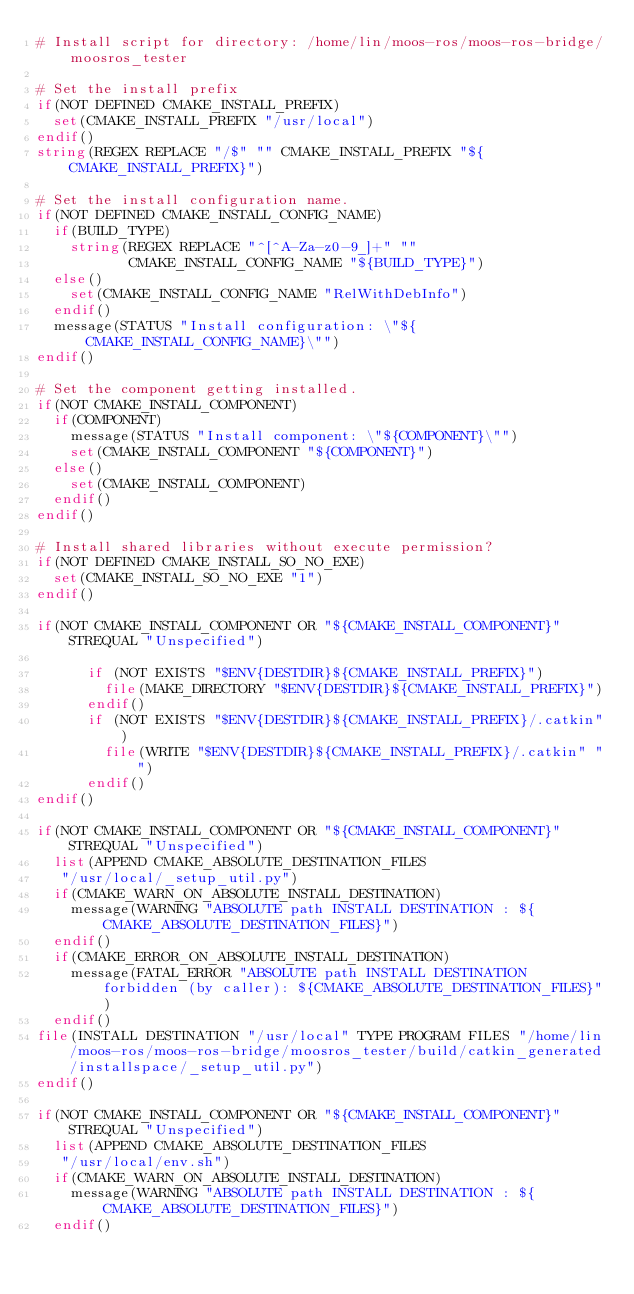Convert code to text. <code><loc_0><loc_0><loc_500><loc_500><_CMake_># Install script for directory: /home/lin/moos-ros/moos-ros-bridge/moosros_tester

# Set the install prefix
if(NOT DEFINED CMAKE_INSTALL_PREFIX)
  set(CMAKE_INSTALL_PREFIX "/usr/local")
endif()
string(REGEX REPLACE "/$" "" CMAKE_INSTALL_PREFIX "${CMAKE_INSTALL_PREFIX}")

# Set the install configuration name.
if(NOT DEFINED CMAKE_INSTALL_CONFIG_NAME)
  if(BUILD_TYPE)
    string(REGEX REPLACE "^[^A-Za-z0-9_]+" ""
           CMAKE_INSTALL_CONFIG_NAME "${BUILD_TYPE}")
  else()
    set(CMAKE_INSTALL_CONFIG_NAME "RelWithDebInfo")
  endif()
  message(STATUS "Install configuration: \"${CMAKE_INSTALL_CONFIG_NAME}\"")
endif()

# Set the component getting installed.
if(NOT CMAKE_INSTALL_COMPONENT)
  if(COMPONENT)
    message(STATUS "Install component: \"${COMPONENT}\"")
    set(CMAKE_INSTALL_COMPONENT "${COMPONENT}")
  else()
    set(CMAKE_INSTALL_COMPONENT)
  endif()
endif()

# Install shared libraries without execute permission?
if(NOT DEFINED CMAKE_INSTALL_SO_NO_EXE)
  set(CMAKE_INSTALL_SO_NO_EXE "1")
endif()

if(NOT CMAKE_INSTALL_COMPONENT OR "${CMAKE_INSTALL_COMPONENT}" STREQUAL "Unspecified")
  
      if (NOT EXISTS "$ENV{DESTDIR}${CMAKE_INSTALL_PREFIX}")
        file(MAKE_DIRECTORY "$ENV{DESTDIR}${CMAKE_INSTALL_PREFIX}")
      endif()
      if (NOT EXISTS "$ENV{DESTDIR}${CMAKE_INSTALL_PREFIX}/.catkin")
        file(WRITE "$ENV{DESTDIR}${CMAKE_INSTALL_PREFIX}/.catkin" "")
      endif()
endif()

if(NOT CMAKE_INSTALL_COMPONENT OR "${CMAKE_INSTALL_COMPONENT}" STREQUAL "Unspecified")
  list(APPEND CMAKE_ABSOLUTE_DESTINATION_FILES
   "/usr/local/_setup_util.py")
  if(CMAKE_WARN_ON_ABSOLUTE_INSTALL_DESTINATION)
    message(WARNING "ABSOLUTE path INSTALL DESTINATION : ${CMAKE_ABSOLUTE_DESTINATION_FILES}")
  endif()
  if(CMAKE_ERROR_ON_ABSOLUTE_INSTALL_DESTINATION)
    message(FATAL_ERROR "ABSOLUTE path INSTALL DESTINATION forbidden (by caller): ${CMAKE_ABSOLUTE_DESTINATION_FILES}")
  endif()
file(INSTALL DESTINATION "/usr/local" TYPE PROGRAM FILES "/home/lin/moos-ros/moos-ros-bridge/moosros_tester/build/catkin_generated/installspace/_setup_util.py")
endif()

if(NOT CMAKE_INSTALL_COMPONENT OR "${CMAKE_INSTALL_COMPONENT}" STREQUAL "Unspecified")
  list(APPEND CMAKE_ABSOLUTE_DESTINATION_FILES
   "/usr/local/env.sh")
  if(CMAKE_WARN_ON_ABSOLUTE_INSTALL_DESTINATION)
    message(WARNING "ABSOLUTE path INSTALL DESTINATION : ${CMAKE_ABSOLUTE_DESTINATION_FILES}")
  endif()</code> 